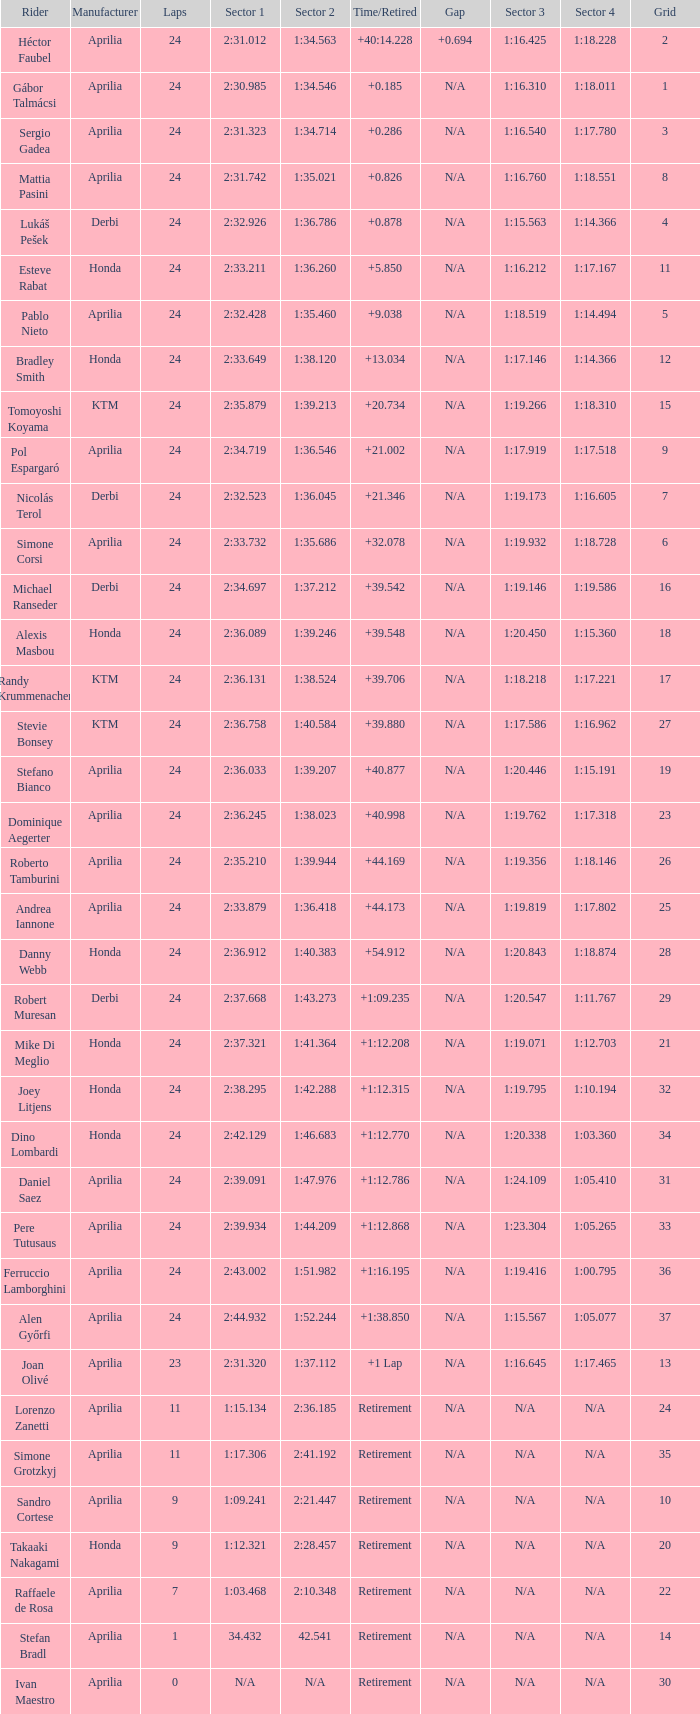What is the time with 10 grids? Retirement. 